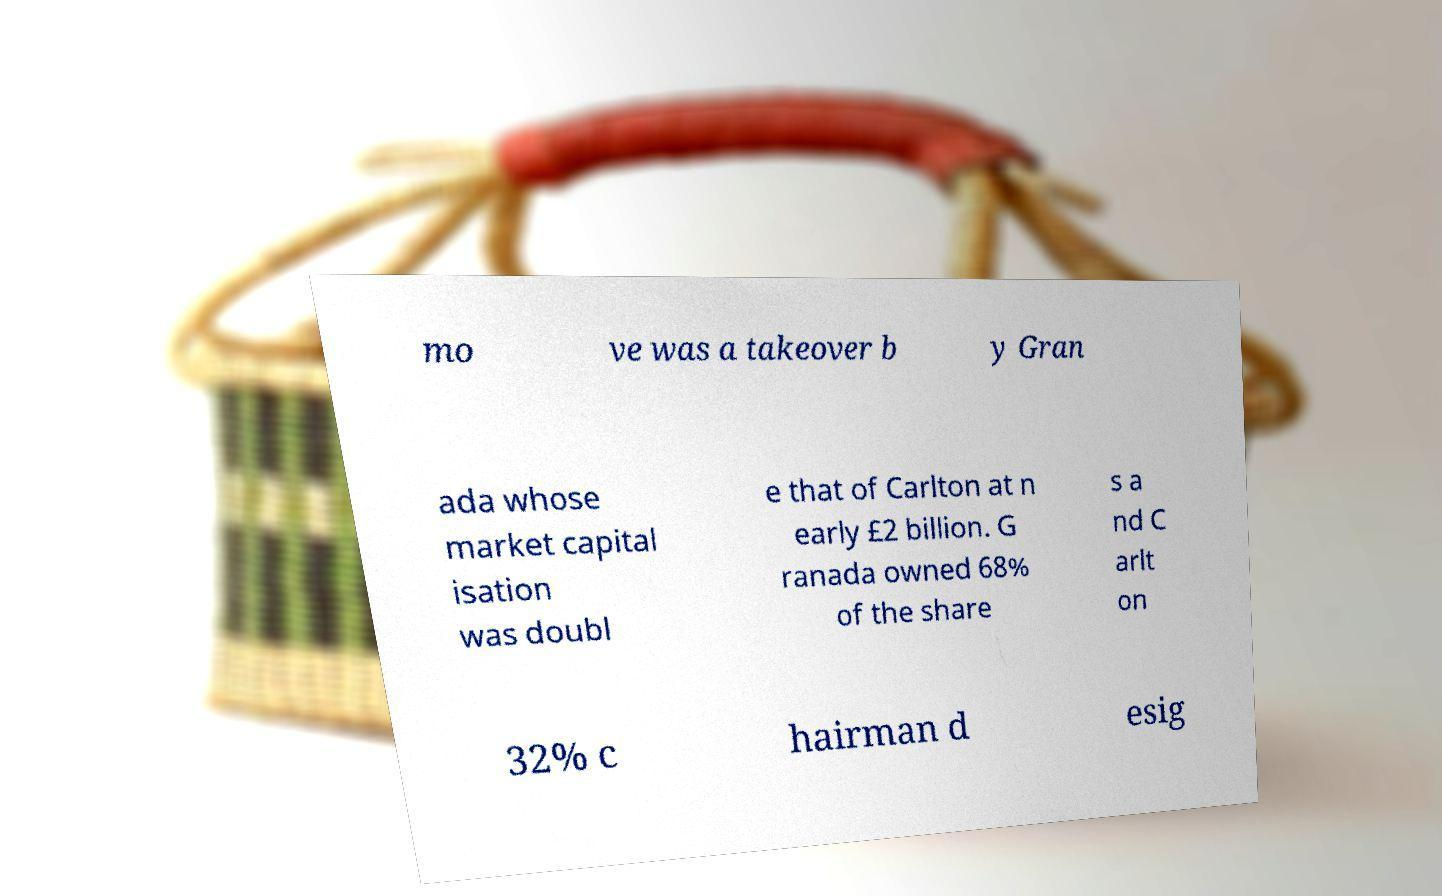There's text embedded in this image that I need extracted. Can you transcribe it verbatim? mo ve was a takeover b y Gran ada whose market capital isation was doubl e that of Carlton at n early £2 billion. G ranada owned 68% of the share s a nd C arlt on 32% c hairman d esig 